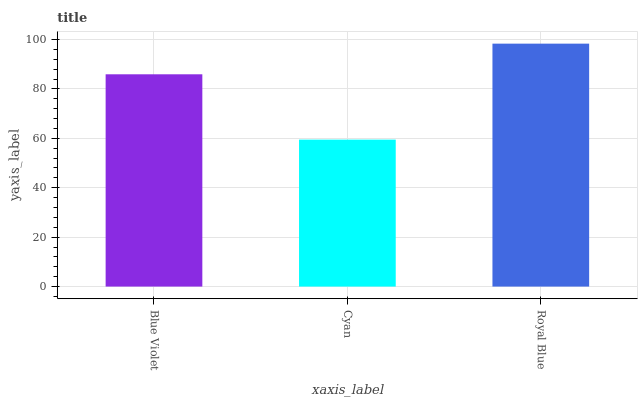Is Cyan the minimum?
Answer yes or no. Yes. Is Royal Blue the maximum?
Answer yes or no. Yes. Is Royal Blue the minimum?
Answer yes or no. No. Is Cyan the maximum?
Answer yes or no. No. Is Royal Blue greater than Cyan?
Answer yes or no. Yes. Is Cyan less than Royal Blue?
Answer yes or no. Yes. Is Cyan greater than Royal Blue?
Answer yes or no. No. Is Royal Blue less than Cyan?
Answer yes or no. No. Is Blue Violet the high median?
Answer yes or no. Yes. Is Blue Violet the low median?
Answer yes or no. Yes. Is Cyan the high median?
Answer yes or no. No. Is Royal Blue the low median?
Answer yes or no. No. 